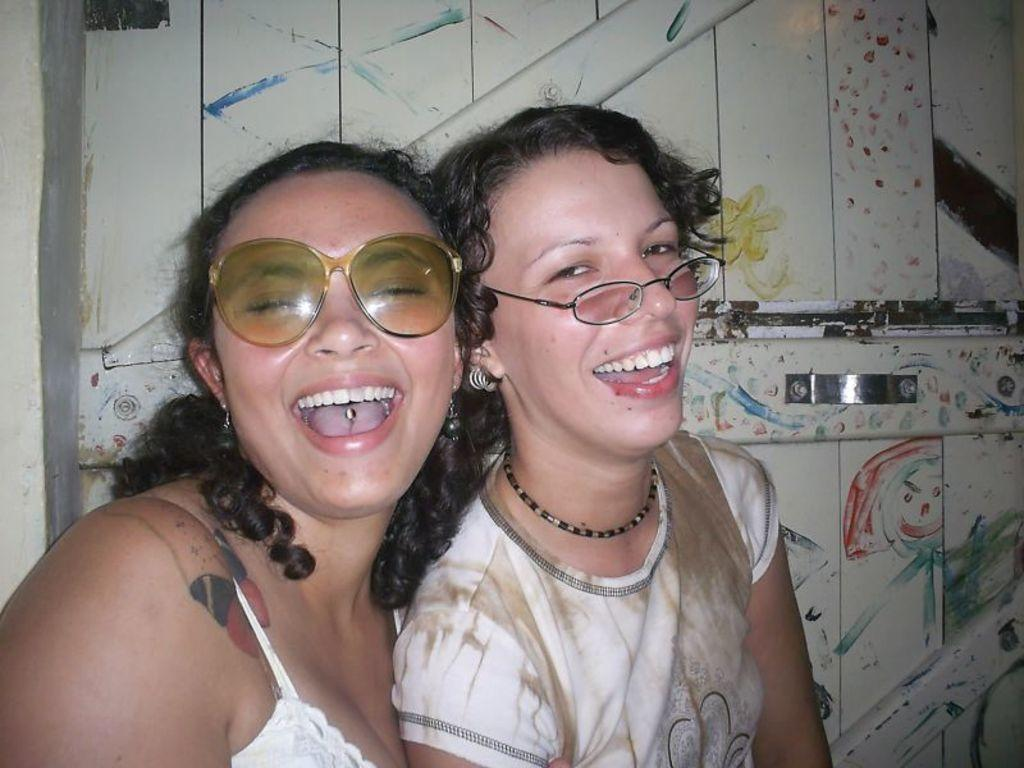How many women are in the image? There are two women in the image. What is the difference in their eyewear? One woman is wearing goggles, and the other woman is wearing spectacles. What can be seen in the background of the image? There is a wall with a handle in the background of the image. What type of reaction can be seen on the stove in the image? There is no stove present in the image, so it is not possible to observe any reaction. 